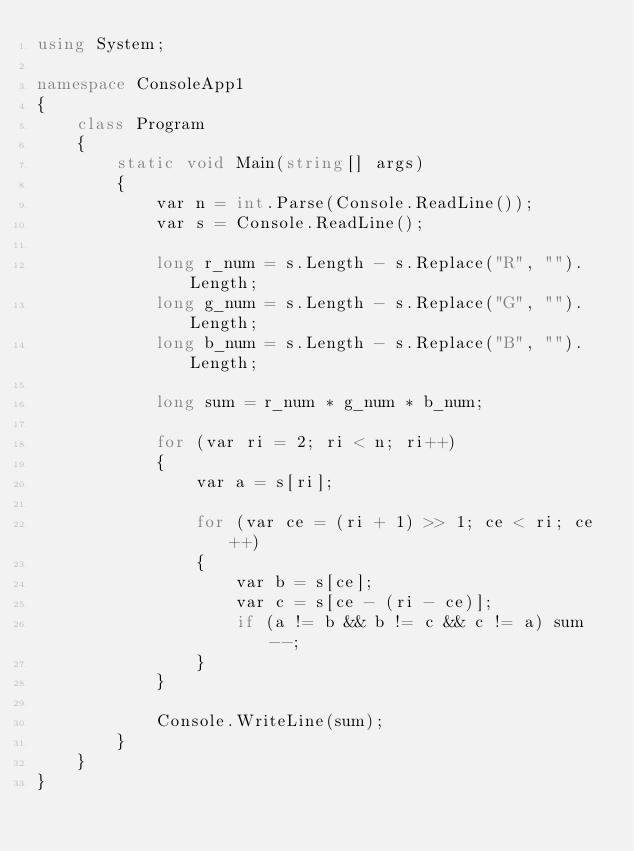<code> <loc_0><loc_0><loc_500><loc_500><_C#_>using System;

namespace ConsoleApp1
{
    class Program
    {
        static void Main(string[] args)
        {
            var n = int.Parse(Console.ReadLine());
            var s = Console.ReadLine();

            long r_num = s.Length - s.Replace("R", "").Length;
            long g_num = s.Length - s.Replace("G", "").Length;
            long b_num = s.Length - s.Replace("B", "").Length;

            long sum = r_num * g_num * b_num;

            for (var ri = 2; ri < n; ri++)
            {
                var a = s[ri];

                for (var ce = (ri + 1) >> 1; ce < ri; ce++)
                {
                    var b = s[ce];
                    var c = s[ce - (ri - ce)];
                    if (a != b && b != c && c != a) sum--;
                }
            }

            Console.WriteLine(sum);
        }
    }
}</code> 